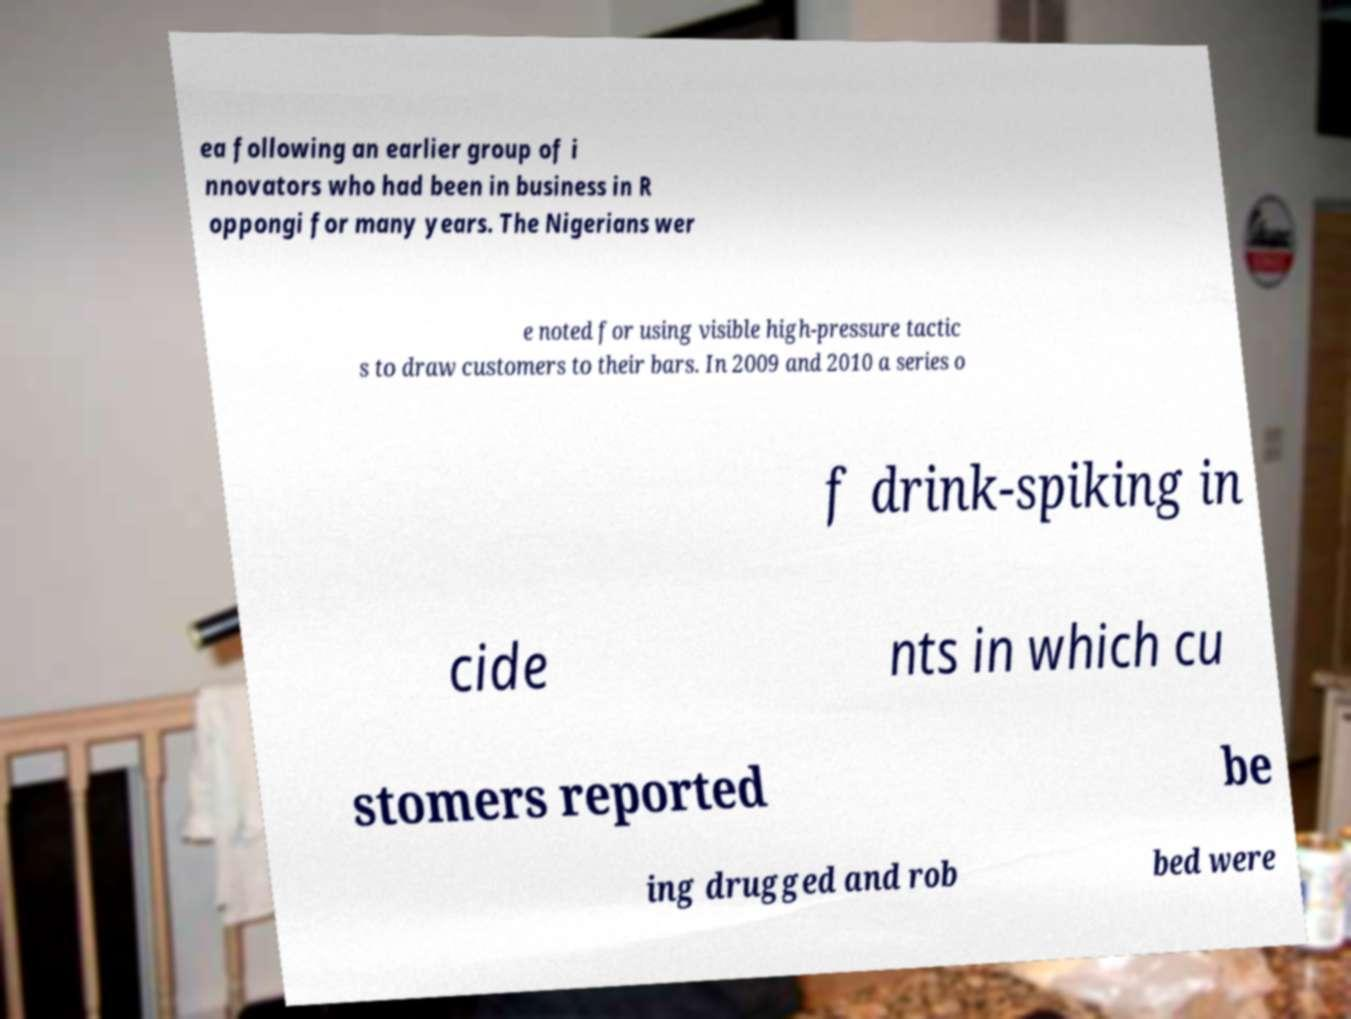Please identify and transcribe the text found in this image. ea following an earlier group of i nnovators who had been in business in R oppongi for many years. The Nigerians wer e noted for using visible high-pressure tactic s to draw customers to their bars. In 2009 and 2010 a series o f drink-spiking in cide nts in which cu stomers reported be ing drugged and rob bed were 